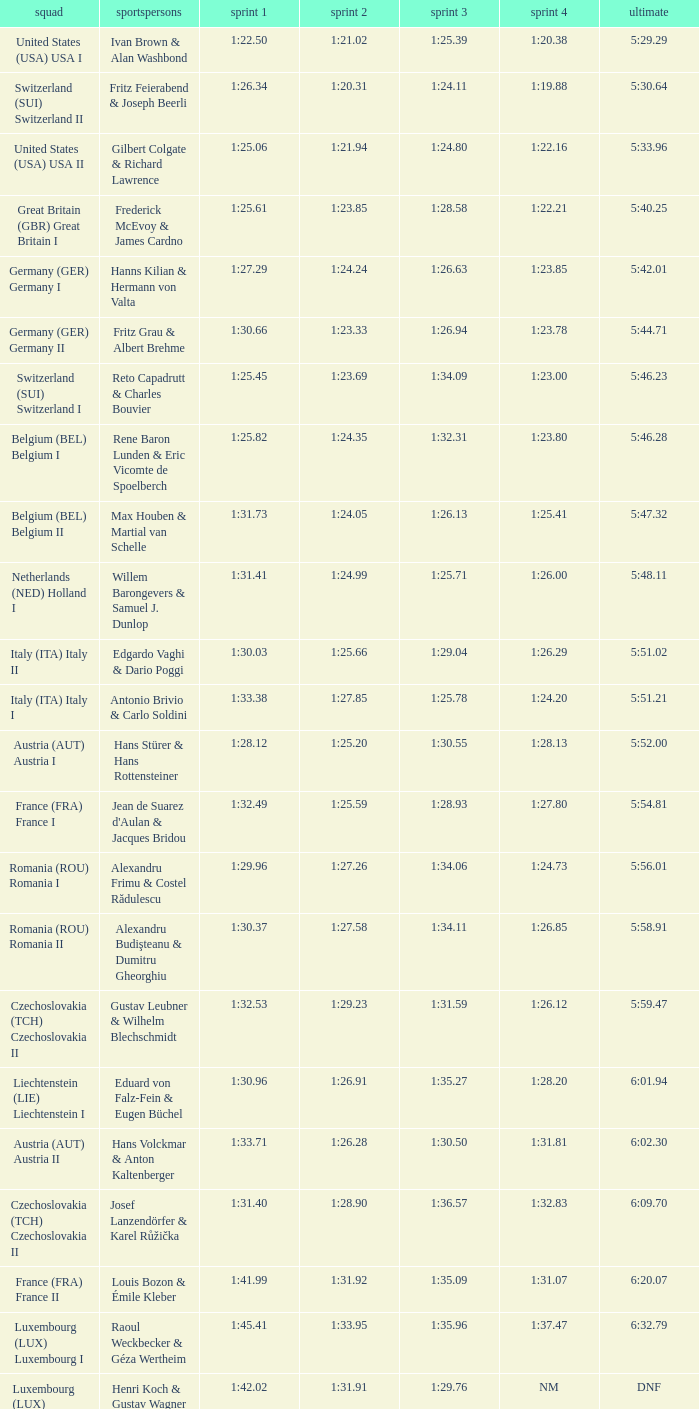Which Final has a Run 2 of 1:27.58? 5:58.91. 